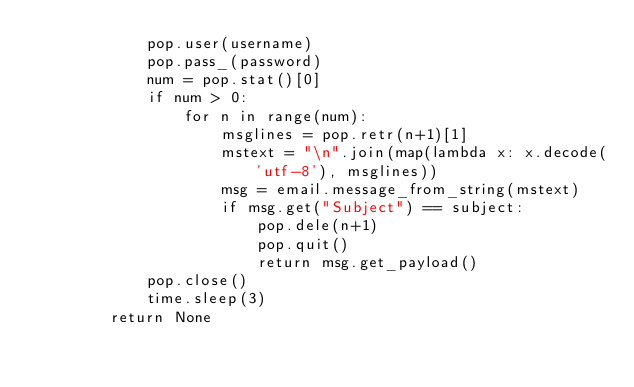<code> <loc_0><loc_0><loc_500><loc_500><_Python_>            pop.user(username)
            pop.pass_(password)
            num = pop.stat()[0]
            if num > 0:
                for n in range(num):
                    msglines = pop.retr(n+1)[1]
                    mstext = "\n".join(map(lambda x: x.decode('utf-8'), msglines))
                    msg = email.message_from_string(mstext)
                    if msg.get("Subject") == subject:
                        pop.dele(n+1)
                        pop.quit()
                        return msg.get_payload()
            pop.close()
            time.sleep(3)
        return None</code> 